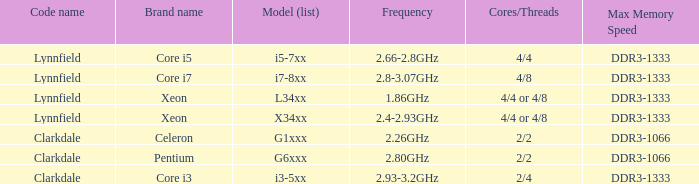What frequency does model L34xx use? 1.86GHz. 